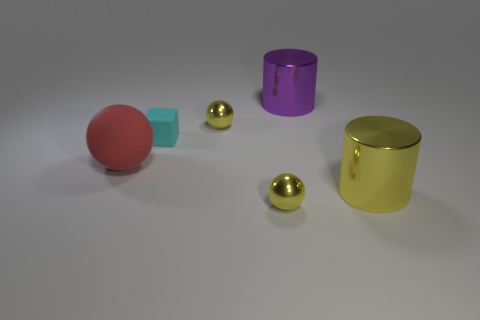Add 4 big red balls. How many objects exist? 10 Subtract all cylinders. How many objects are left? 4 Add 3 brown cubes. How many brown cubes exist? 3 Subtract 0 gray blocks. How many objects are left? 6 Subtract all cylinders. Subtract all big things. How many objects are left? 1 Add 2 red objects. How many red objects are left? 3 